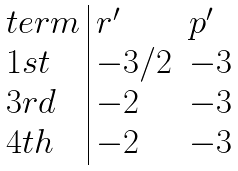<formula> <loc_0><loc_0><loc_500><loc_500>\begin{array} { l | l l } t e r m & r ^ { \prime } & p ^ { \prime } \\ 1 s t & - 3 / 2 & - 3 \\ 3 r d & - 2 & - 3 \\ 4 t h & - 2 & - 3 \end{array}</formula> 